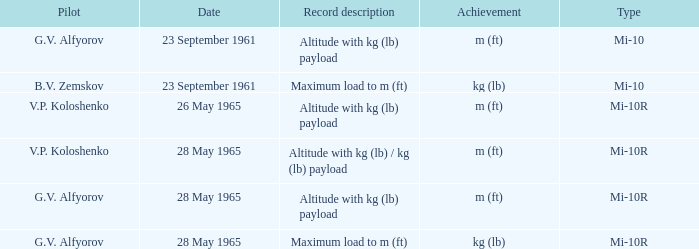Date of 23 september 1961, and a Pilot of b.v. zemskov had what record description? Maximum load to m (ft). 